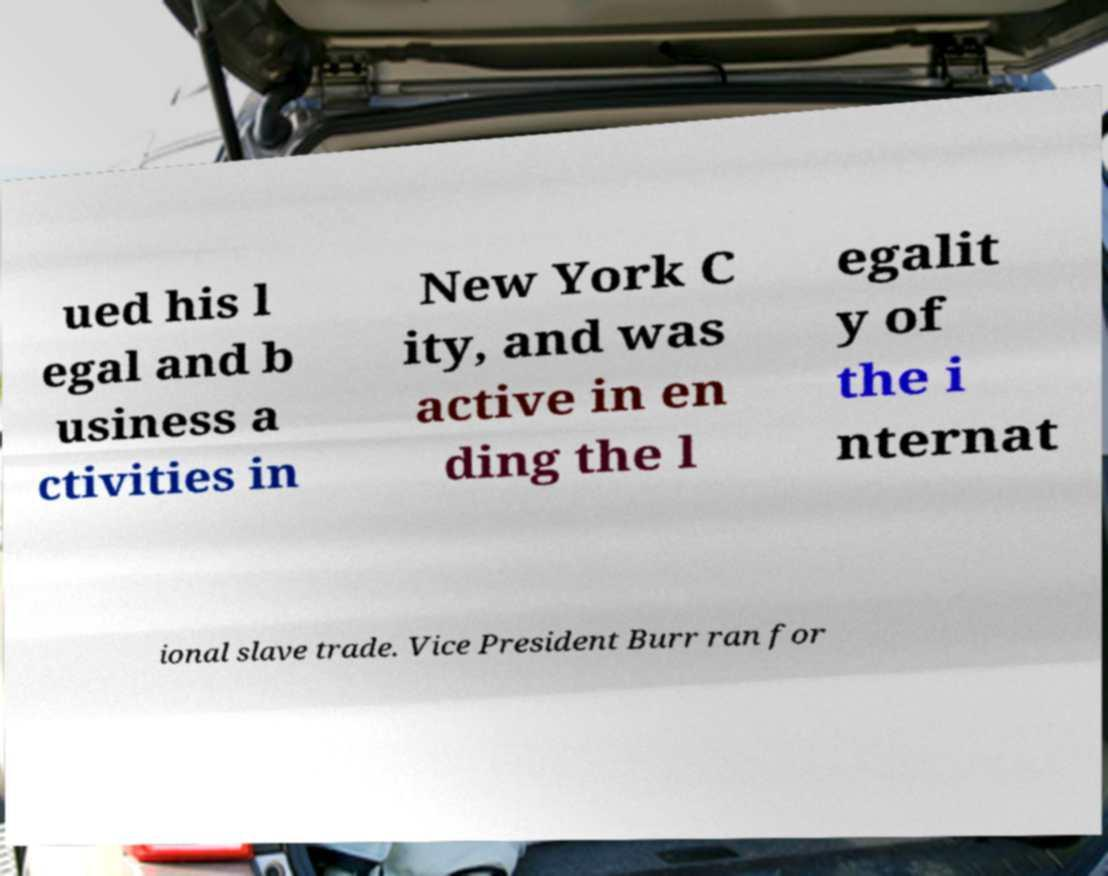I need the written content from this picture converted into text. Can you do that? ued his l egal and b usiness a ctivities in New York C ity, and was active in en ding the l egalit y of the i nternat ional slave trade. Vice President Burr ran for 